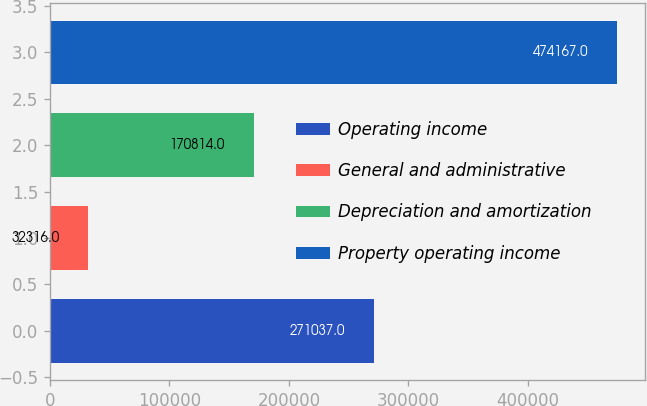Convert chart. <chart><loc_0><loc_0><loc_500><loc_500><bar_chart><fcel>Operating income<fcel>General and administrative<fcel>Depreciation and amortization<fcel>Property operating income<nl><fcel>271037<fcel>32316<fcel>170814<fcel>474167<nl></chart> 